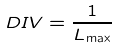Convert formula to latex. <formula><loc_0><loc_0><loc_500><loc_500>D I V = \frac { 1 } { L _ { \max } }</formula> 